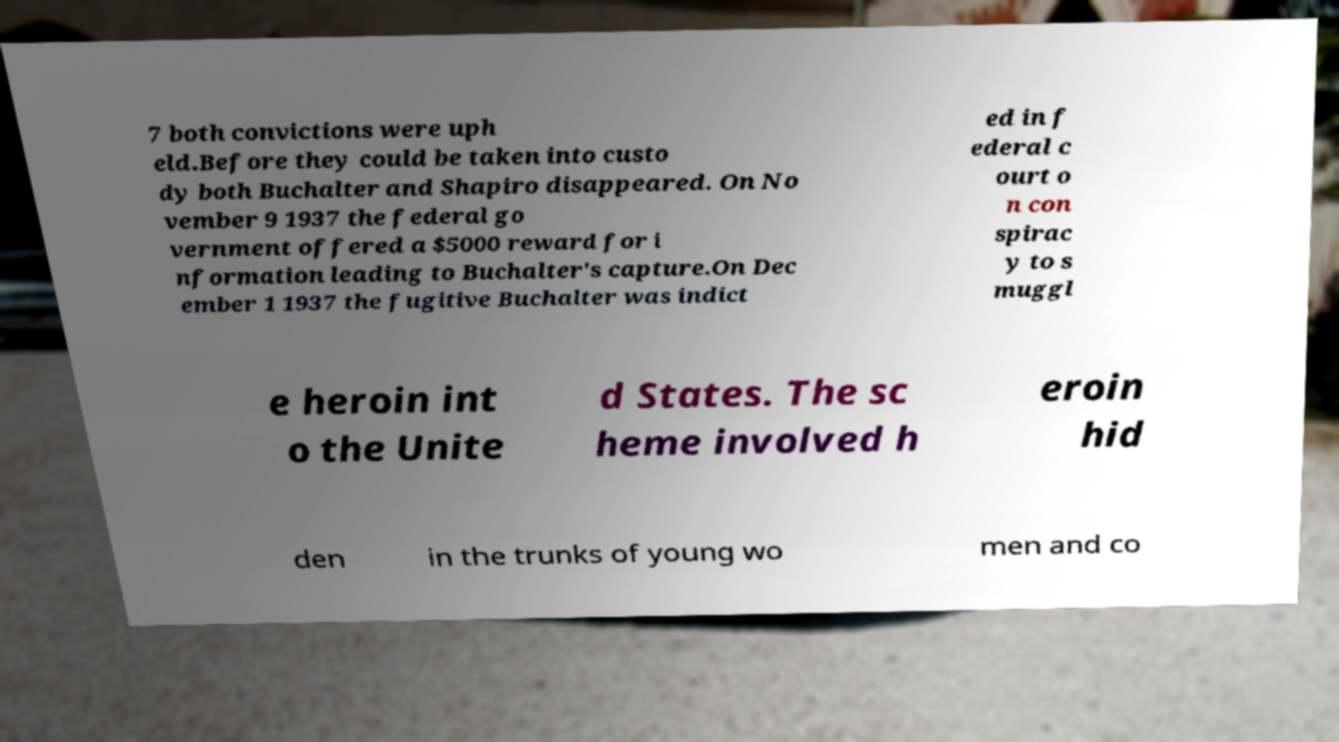For documentation purposes, I need the text within this image transcribed. Could you provide that? 7 both convictions were uph eld.Before they could be taken into custo dy both Buchalter and Shapiro disappeared. On No vember 9 1937 the federal go vernment offered a $5000 reward for i nformation leading to Buchalter's capture.On Dec ember 1 1937 the fugitive Buchalter was indict ed in f ederal c ourt o n con spirac y to s muggl e heroin int o the Unite d States. The sc heme involved h eroin hid den in the trunks of young wo men and co 